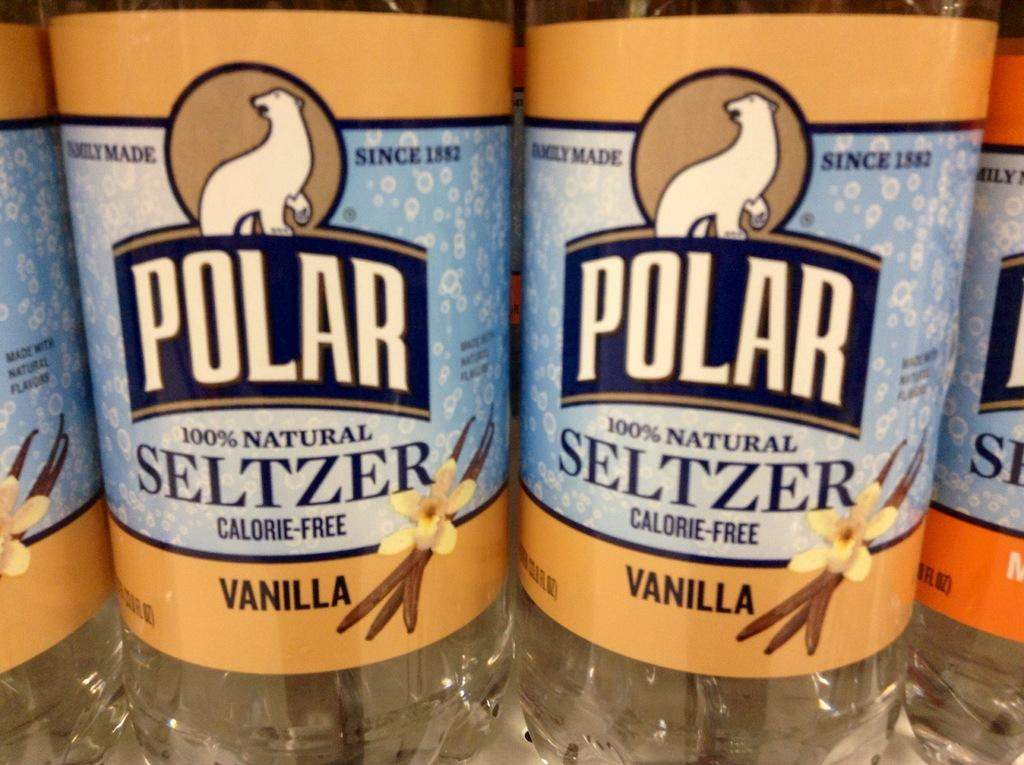<image>
Share a concise interpretation of the image provided. A row of Polar Seltzer Vanilla brand drinks on a shelf 